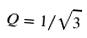<formula> <loc_0><loc_0><loc_500><loc_500>Q = 1 / \sqrt { 3 }</formula> 